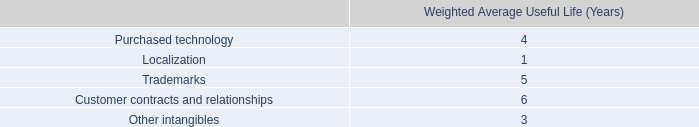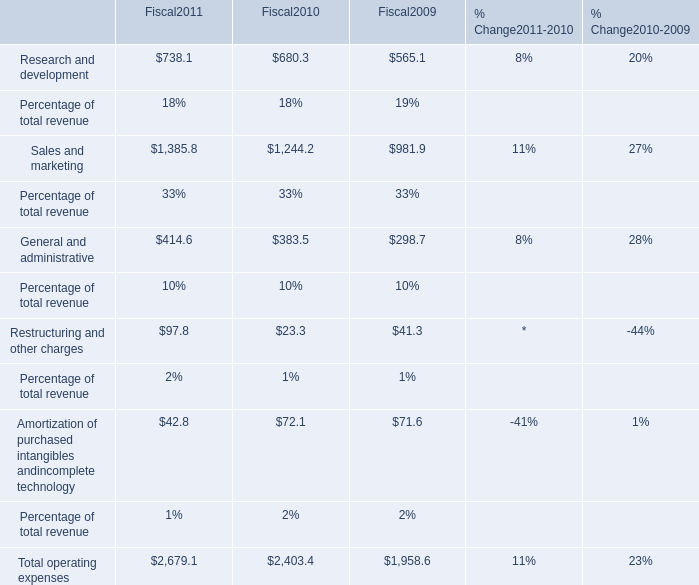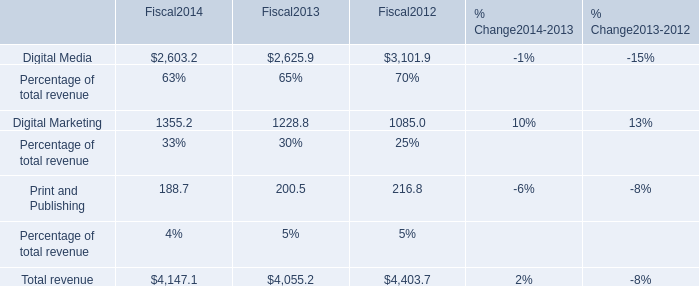What's the average of Digital Marketing of Fiscal2014, and Sales and marketing of Fiscal2010 ? 
Computations: ((1355.2 + 1244.2) / 2)
Answer: 1299.7. 